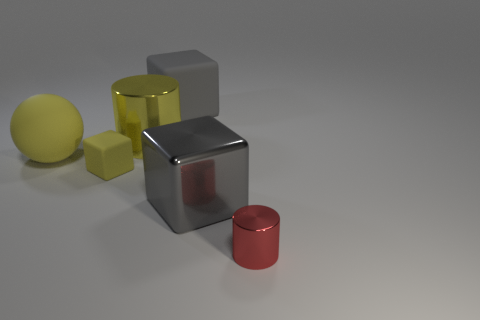Subtract all big gray cubes. How many cubes are left? 1 Add 2 small yellow rubber objects. How many objects exist? 8 Subtract all yellow cubes. How many cubes are left? 2 Subtract all cylinders. How many objects are left? 4 Subtract all purple spheres. How many gray blocks are left? 2 Subtract 2 cubes. How many cubes are left? 1 Subtract 0 blue cylinders. How many objects are left? 6 Subtract all brown cylinders. Subtract all cyan balls. How many cylinders are left? 2 Subtract all brown metallic objects. Subtract all tiny red cylinders. How many objects are left? 5 Add 5 gray metallic things. How many gray metallic things are left? 6 